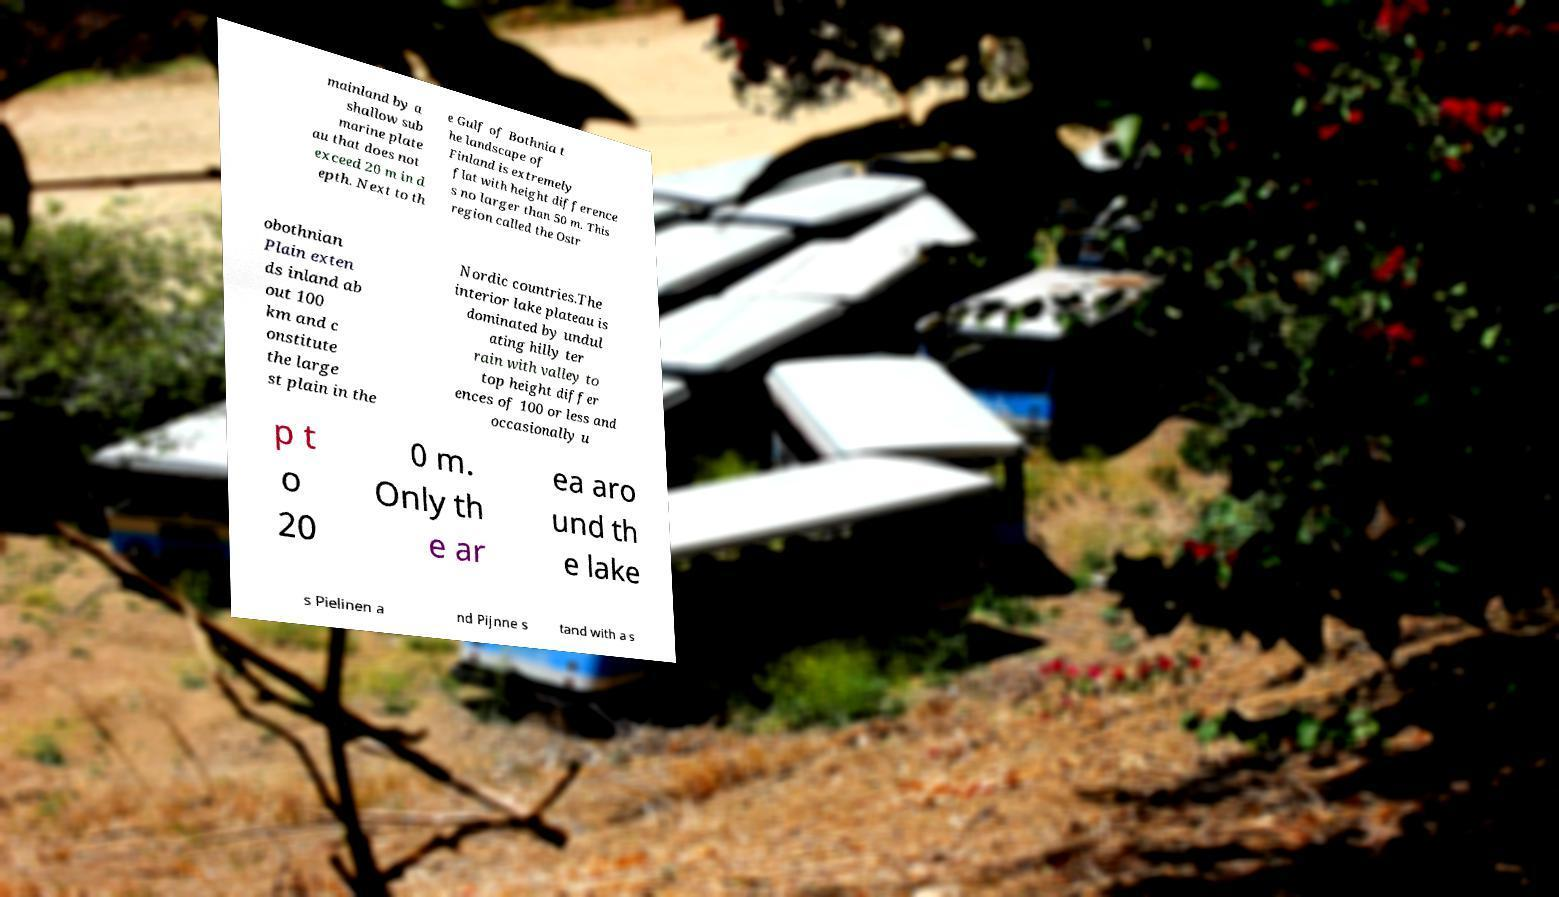Could you extract and type out the text from this image? mainland by a shallow sub marine plate au that does not exceed 20 m in d epth. Next to th e Gulf of Bothnia t he landscape of Finland is extremely flat with height difference s no larger than 50 m. This region called the Ostr obothnian Plain exten ds inland ab out 100 km and c onstitute the large st plain in the Nordic countries.The interior lake plateau is dominated by undul ating hilly ter rain with valley to top height differ ences of 100 or less and occasionally u p t o 20 0 m. Only th e ar ea aro und th e lake s Pielinen a nd Pijnne s tand with a s 